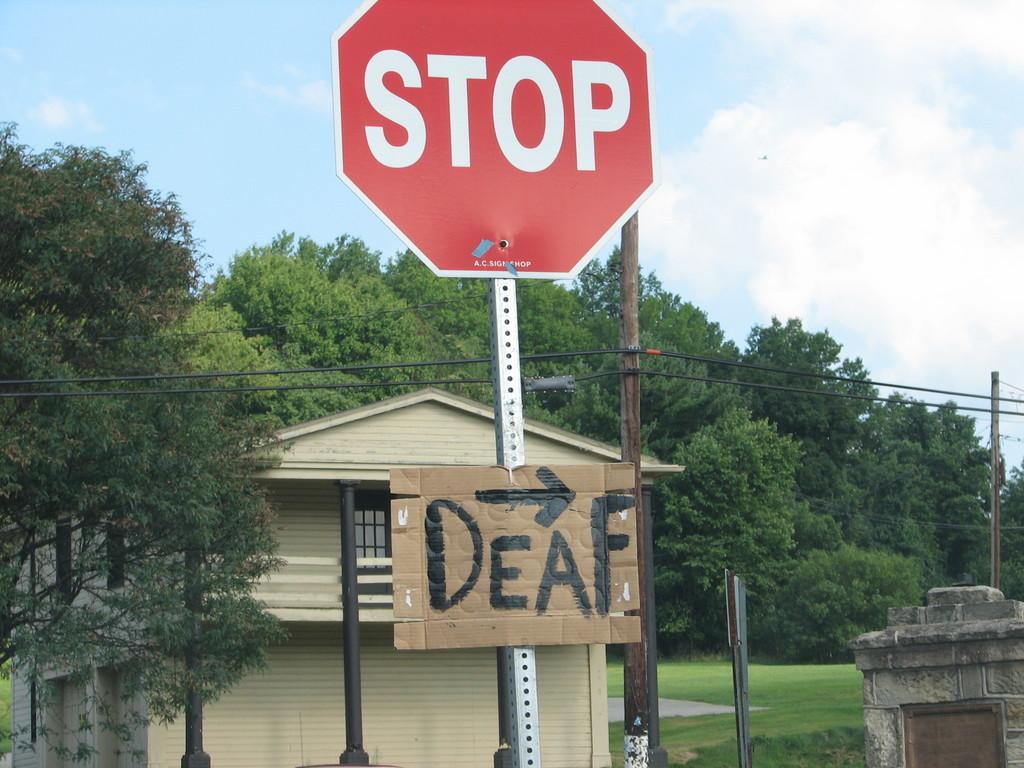What is to the right?
Offer a very short reply. Deaf. What does the red sign say?
Your response must be concise. Stop. 